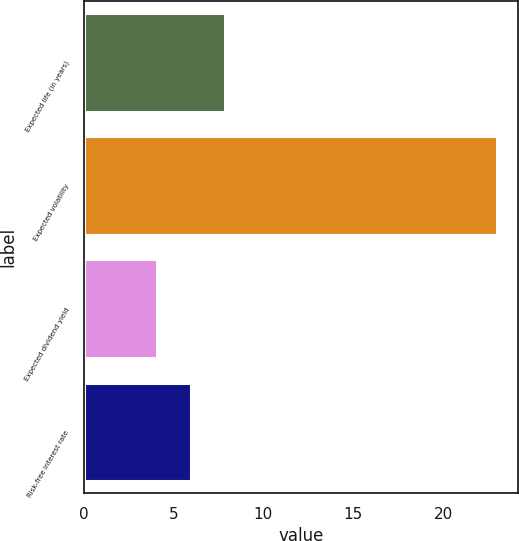<chart> <loc_0><loc_0><loc_500><loc_500><bar_chart><fcel>Expected life (in years)<fcel>Expected volatility<fcel>Expected dividend yield<fcel>Risk-free interest rate<nl><fcel>7.88<fcel>23<fcel>4.1<fcel>5.99<nl></chart> 